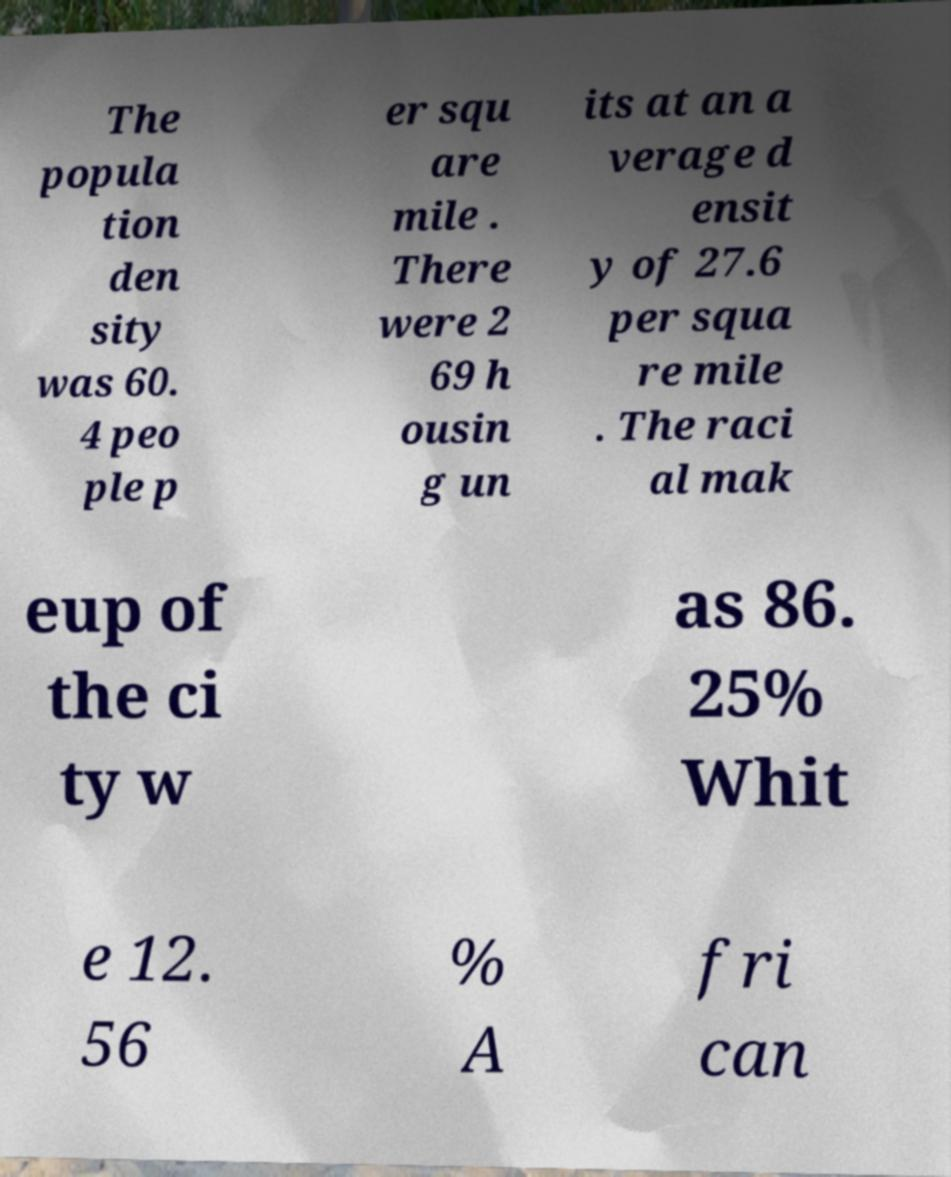What messages or text are displayed in this image? I need them in a readable, typed format. The popula tion den sity was 60. 4 peo ple p er squ are mile . There were 2 69 h ousin g un its at an a verage d ensit y of 27.6 per squa re mile . The raci al mak eup of the ci ty w as 86. 25% Whit e 12. 56 % A fri can 